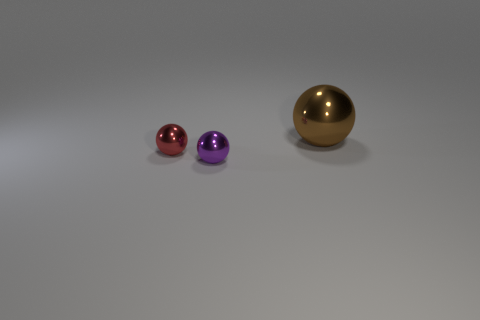Add 1 big cyan matte cylinders. How many objects exist? 4 Subtract 0 red cylinders. How many objects are left? 3 Subtract all purple balls. Subtract all big purple rubber cylinders. How many objects are left? 2 Add 2 big brown balls. How many big brown balls are left? 3 Add 1 big brown spheres. How many big brown spheres exist? 2 